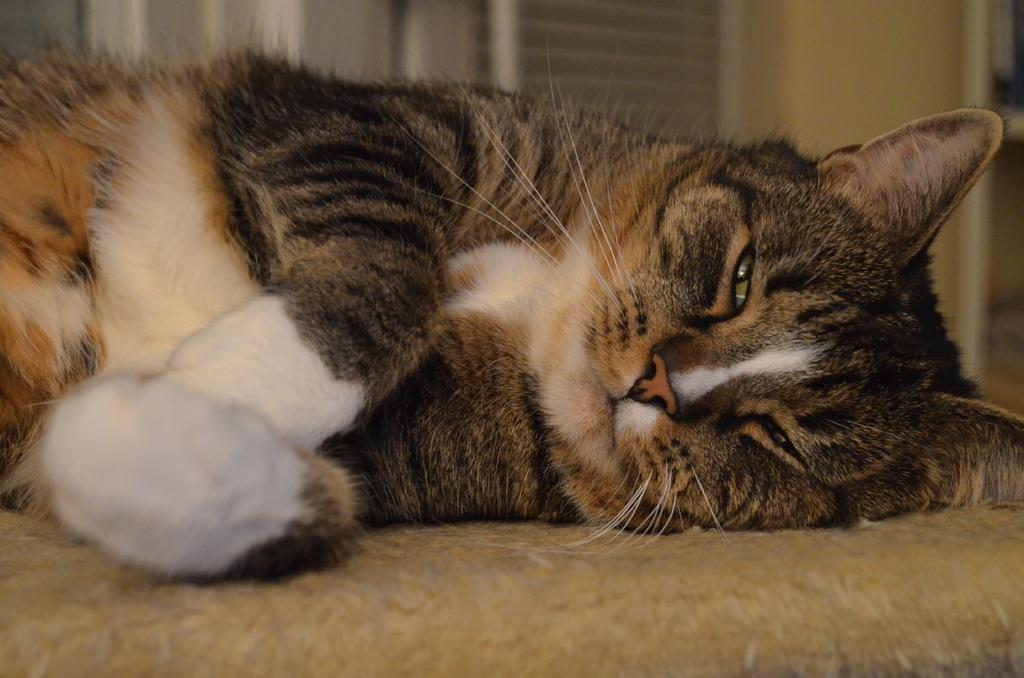What type of animal is in the image? There is a cat in the image. Can you describe the cat's fur color? The cat has white, brown, and black colors. Where is the cat located in the image? The cat is on a brown surface. What can be seen in the background of the image? There is a wall in the background of the image. How is the wall depicted in the image? The wall is blurry. What type of soap is the cat using to clean itself in the image? There is no soap present in the image, and the cat is not shown cleaning itself. 